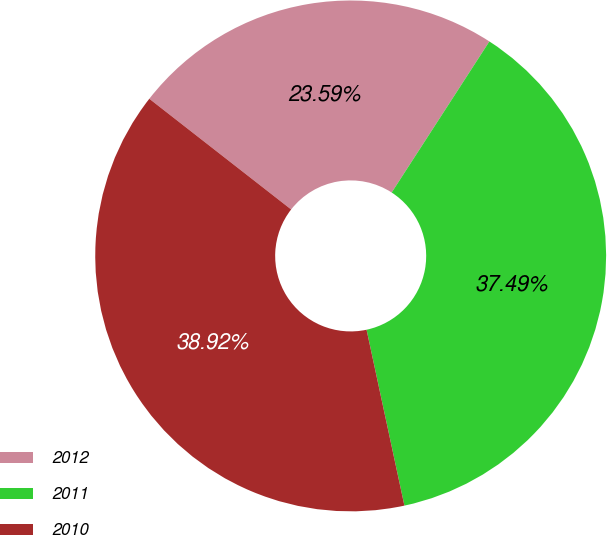<chart> <loc_0><loc_0><loc_500><loc_500><pie_chart><fcel>2012<fcel>2011<fcel>2010<nl><fcel>23.59%<fcel>37.49%<fcel>38.92%<nl></chart> 